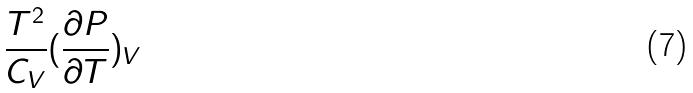Convert formula to latex. <formula><loc_0><loc_0><loc_500><loc_500>\frac { T ^ { 2 } } { C _ { V } } ( \frac { \partial P } { \partial T } ) _ { V }</formula> 